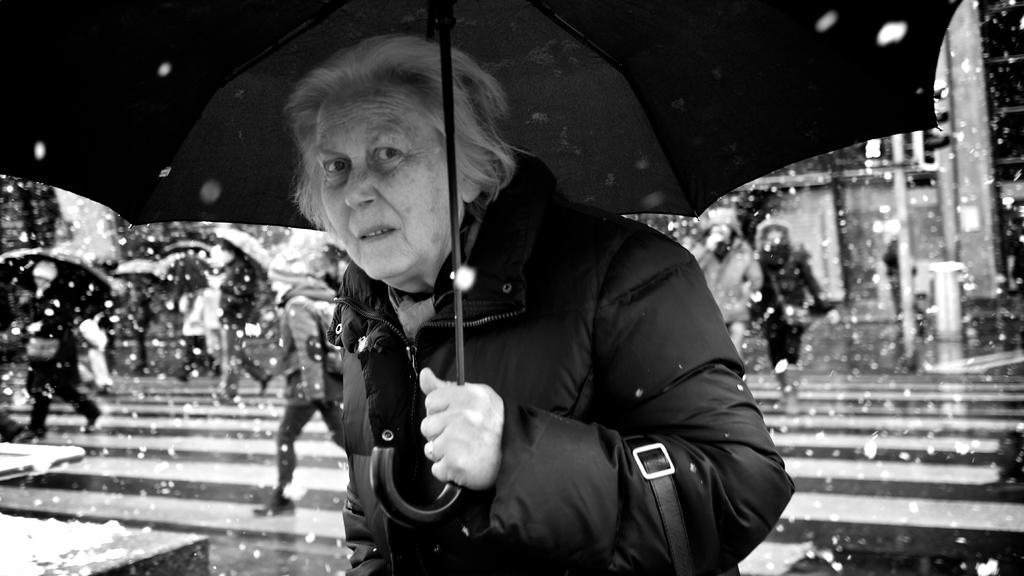How would you summarize this image in a sentence or two? It looks like a black and white picture. We can see a person in the jacket is holding an umbrella. Behind the person there are some people walking and some blurred objects. 